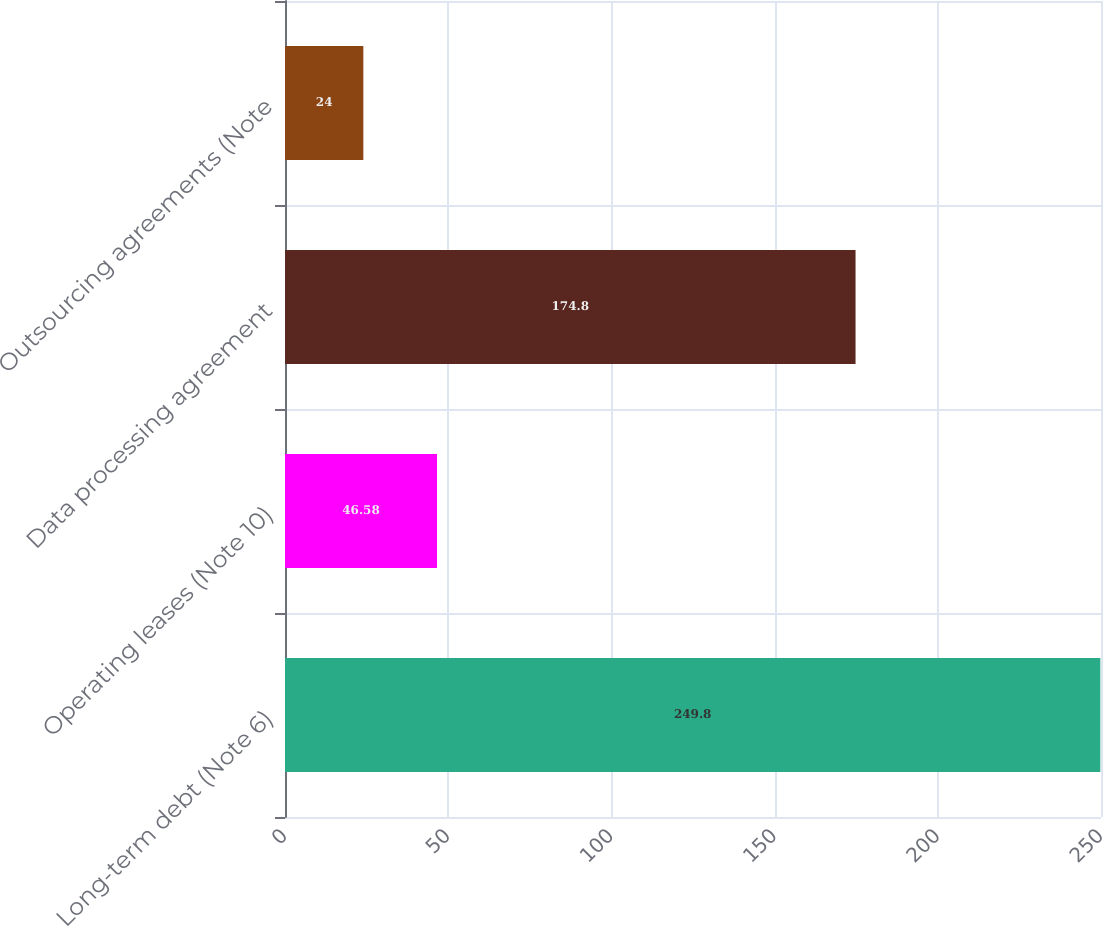Convert chart to OTSL. <chart><loc_0><loc_0><loc_500><loc_500><bar_chart><fcel>Long-term debt (Note 6)<fcel>Operating leases (Note 10)<fcel>Data processing agreement<fcel>Outsourcing agreements (Note<nl><fcel>249.8<fcel>46.58<fcel>174.8<fcel>24<nl></chart> 